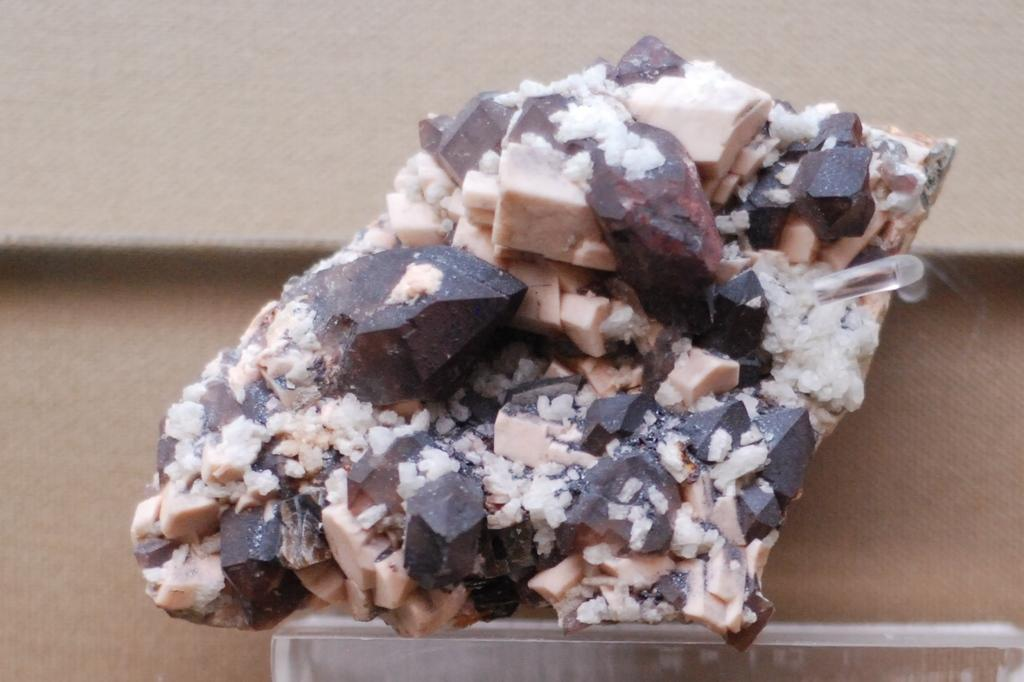What is the main subject of the image? There is a food item in the center of the image. Can you describe the appearance of the food item? The food item is brown and cream in color. What else can be seen in the background of the image? There is a board in the background of the image. How does the sister react to the earthquake in the image? There is no sister or earthquake present in the image; it only features a food item and a board in the background. 